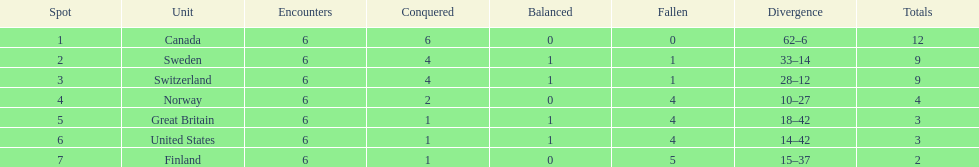Which country's team came in last place during the 1951 world ice hockey championships? Finland. 